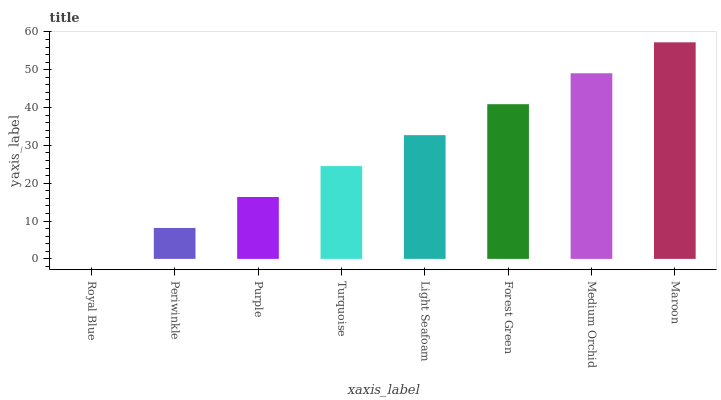Is Royal Blue the minimum?
Answer yes or no. Yes. Is Maroon the maximum?
Answer yes or no. Yes. Is Periwinkle the minimum?
Answer yes or no. No. Is Periwinkle the maximum?
Answer yes or no. No. Is Periwinkle greater than Royal Blue?
Answer yes or no. Yes. Is Royal Blue less than Periwinkle?
Answer yes or no. Yes. Is Royal Blue greater than Periwinkle?
Answer yes or no. No. Is Periwinkle less than Royal Blue?
Answer yes or no. No. Is Light Seafoam the high median?
Answer yes or no. Yes. Is Turquoise the low median?
Answer yes or no. Yes. Is Periwinkle the high median?
Answer yes or no. No. Is Periwinkle the low median?
Answer yes or no. No. 